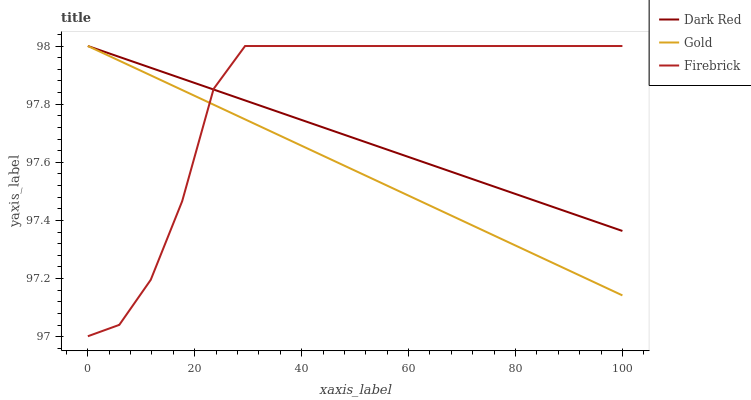Does Firebrick have the minimum area under the curve?
Answer yes or no. No. Does Gold have the maximum area under the curve?
Answer yes or no. No. Is Gold the smoothest?
Answer yes or no. No. Is Gold the roughest?
Answer yes or no. No. Does Gold have the lowest value?
Answer yes or no. No. 